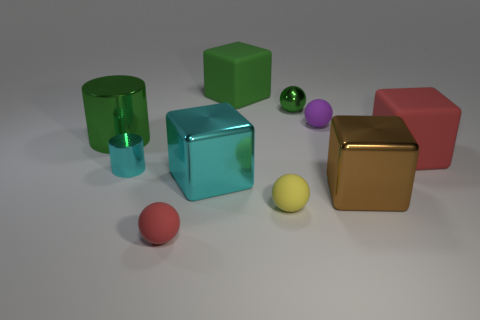Is there any other thing that is made of the same material as the red ball?
Make the answer very short. Yes. What number of cubes are behind the matte ball behind the large rubber object in front of the tiny purple sphere?
Provide a succinct answer. 1. There is a cylinder behind the big red object; is it the same size as the cyan shiny object that is in front of the cyan metal cylinder?
Provide a succinct answer. Yes. What is the green object to the right of the block that is behind the large red rubber object made of?
Ensure brevity in your answer.  Metal. What number of objects are either big cubes that are in front of the small purple thing or red matte cubes?
Provide a short and direct response. 3. Are there an equal number of cyan blocks behind the brown object and big brown things behind the big cyan object?
Your answer should be compact. No. There is a large green thing on the right side of the cylinder that is in front of the big green cylinder on the left side of the small metal cylinder; what is its material?
Keep it short and to the point. Rubber. What size is the cube that is behind the large brown cube and right of the shiny sphere?
Provide a short and direct response. Large. Do the large green metallic thing and the small cyan thing have the same shape?
Provide a succinct answer. Yes. The large red object that is made of the same material as the tiny yellow ball is what shape?
Give a very brief answer. Cube. 